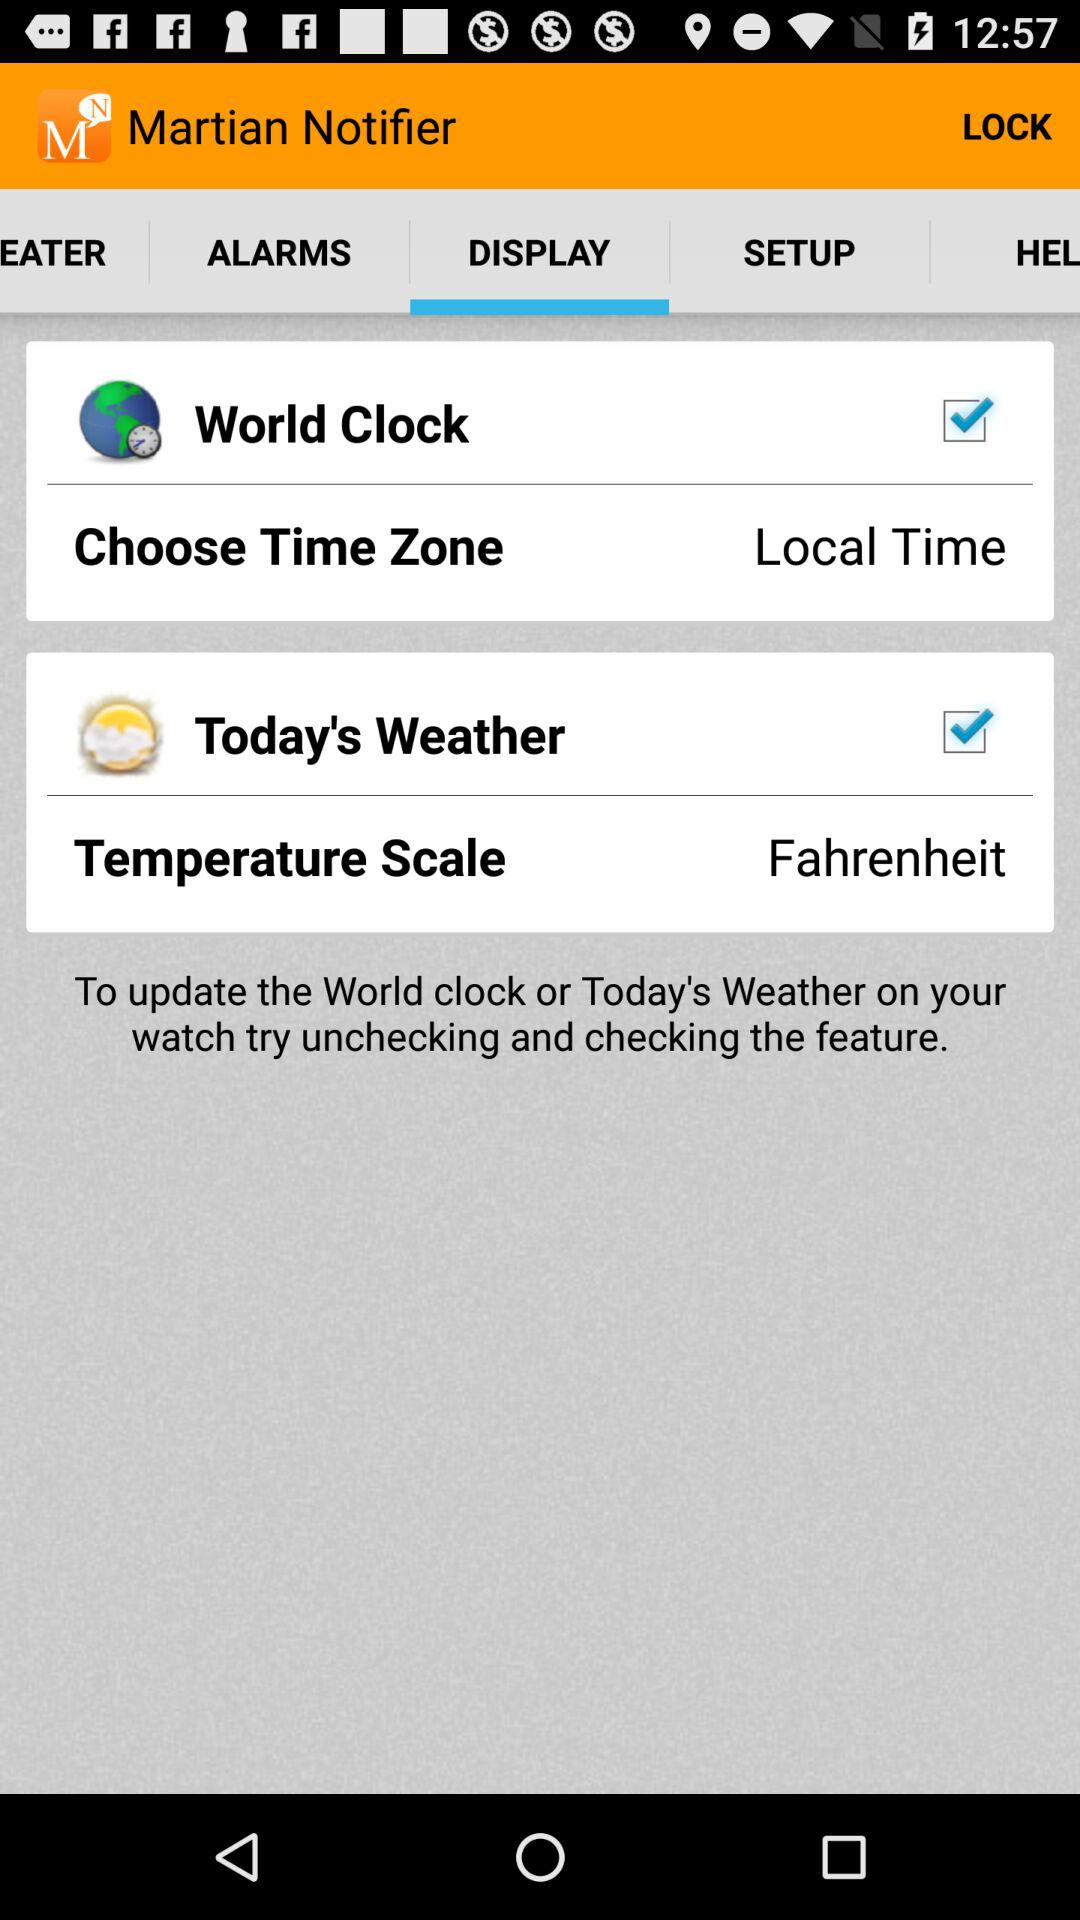Which option is selected on the screen? The selected options are "World Clock" and "Today's Weather". 